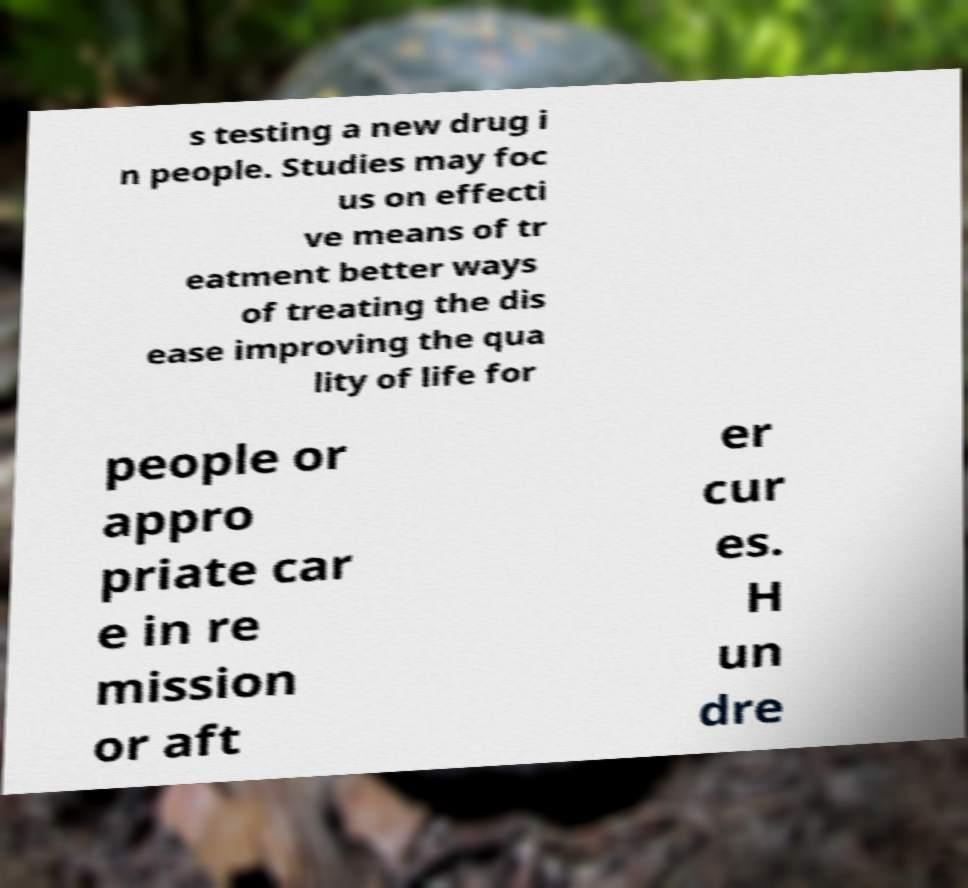Could you extract and type out the text from this image? s testing a new drug i n people. Studies may foc us on effecti ve means of tr eatment better ways of treating the dis ease improving the qua lity of life for people or appro priate car e in re mission or aft er cur es. H un dre 